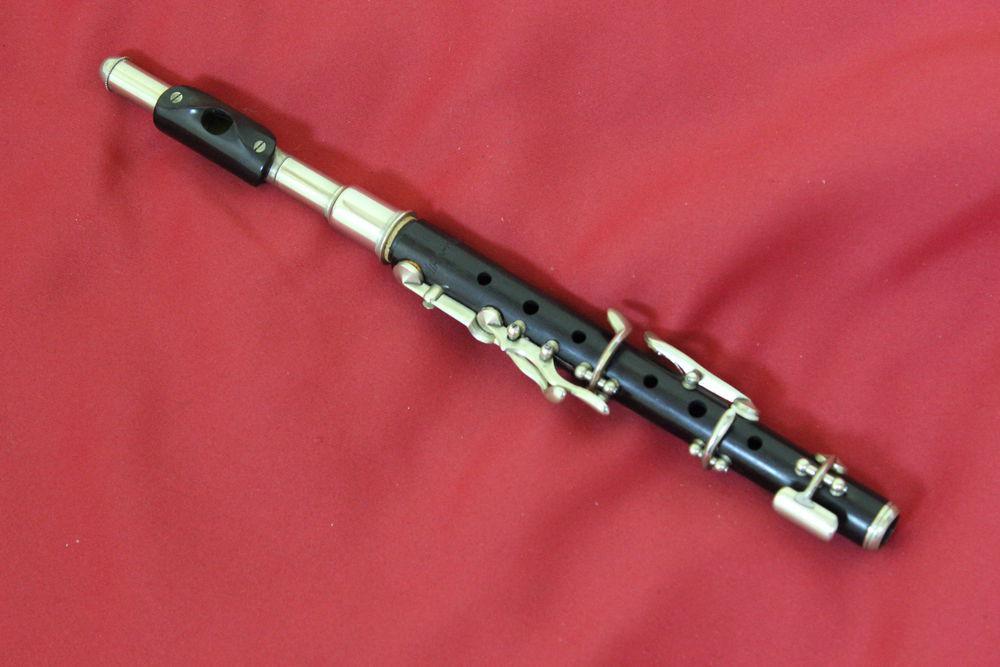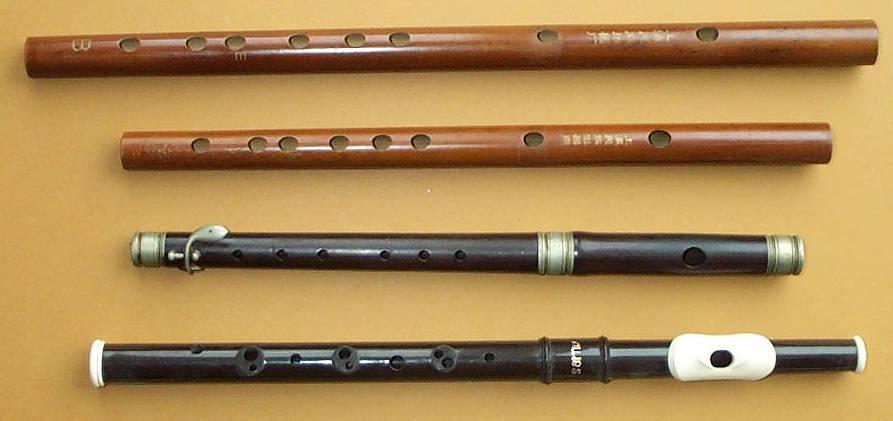The first image is the image on the left, the second image is the image on the right. Analyze the images presented: Is the assertion "The left image contains a single flute displayed at an angle, and the right image includes one flute displayed at an angle opposite that of the flute on the left." valid? Answer yes or no. No. The first image is the image on the left, the second image is the image on the right. Evaluate the accuracy of this statement regarding the images: "The left and right image contains the same number of flutes.". Is it true? Answer yes or no. No. 